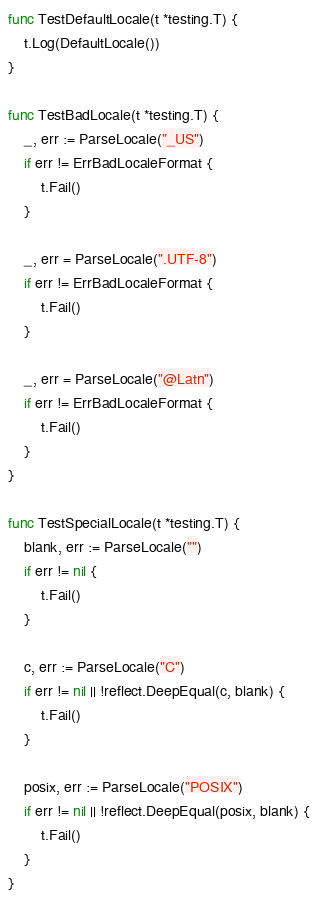Convert code to text. <code><loc_0><loc_0><loc_500><loc_500><_Go_>func TestDefaultLocale(t *testing.T) {
	t.Log(DefaultLocale())
}

func TestBadLocale(t *testing.T) {
	_, err := ParseLocale("_US")
	if err != ErrBadLocaleFormat {
		t.Fail()
	}

	_, err = ParseLocale(".UTF-8")
	if err != ErrBadLocaleFormat {
		t.Fail()
	}

	_, err = ParseLocale("@Latn")
	if err != ErrBadLocaleFormat {
		t.Fail()
	}
}

func TestSpecialLocale(t *testing.T) {
	blank, err := ParseLocale("")
	if err != nil {
		t.Fail()
	}

	c, err := ParseLocale("C")
	if err != nil || !reflect.DeepEqual(c, blank) {
		t.Fail()
	}

	posix, err := ParseLocale("POSIX")
	if err != nil || !reflect.DeepEqual(posix, blank) {
		t.Fail()
	}
}
</code> 